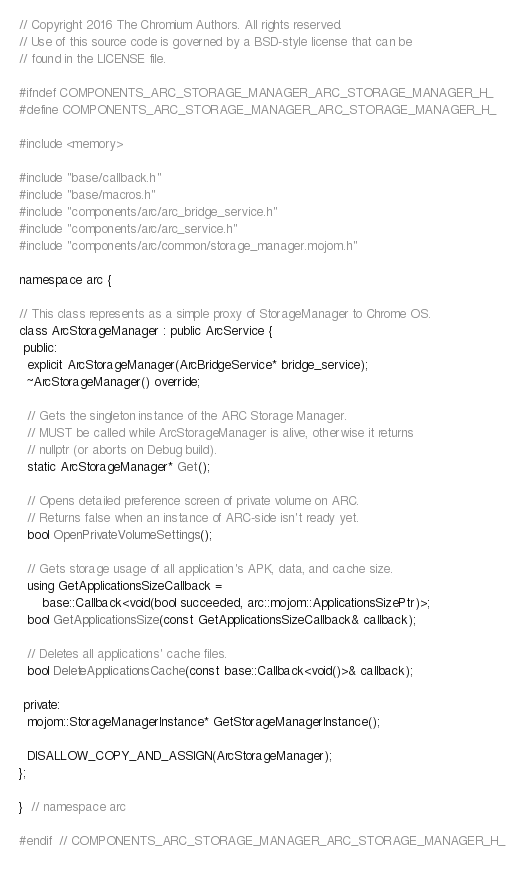<code> <loc_0><loc_0><loc_500><loc_500><_C_>// Copyright 2016 The Chromium Authors. All rights reserved.
// Use of this source code is governed by a BSD-style license that can be
// found in the LICENSE file.

#ifndef COMPONENTS_ARC_STORAGE_MANAGER_ARC_STORAGE_MANAGER_H_
#define COMPONENTS_ARC_STORAGE_MANAGER_ARC_STORAGE_MANAGER_H_

#include <memory>

#include "base/callback.h"
#include "base/macros.h"
#include "components/arc/arc_bridge_service.h"
#include "components/arc/arc_service.h"
#include "components/arc/common/storage_manager.mojom.h"

namespace arc {

// This class represents as a simple proxy of StorageManager to Chrome OS.
class ArcStorageManager : public ArcService {
 public:
  explicit ArcStorageManager(ArcBridgeService* bridge_service);
  ~ArcStorageManager() override;

  // Gets the singleton instance of the ARC Storage Manager.
  // MUST be called while ArcStorageManager is alive, otherwise it returns
  // nullptr (or aborts on Debug build).
  static ArcStorageManager* Get();

  // Opens detailed preference screen of private volume on ARC.
  // Returns false when an instance of ARC-side isn't ready yet.
  bool OpenPrivateVolumeSettings();

  // Gets storage usage of all application's APK, data, and cache size.
  using GetApplicationsSizeCallback =
      base::Callback<void(bool succeeded, arc::mojom::ApplicationsSizePtr)>;
  bool GetApplicationsSize(const GetApplicationsSizeCallback& callback);

  // Deletes all applications' cache files.
  bool DeleteApplicationsCache(const base::Callback<void()>& callback);

 private:
  mojom::StorageManagerInstance* GetStorageManagerInstance();

  DISALLOW_COPY_AND_ASSIGN(ArcStorageManager);
};

}  // namespace arc

#endif  // COMPONENTS_ARC_STORAGE_MANAGER_ARC_STORAGE_MANAGER_H_
</code> 